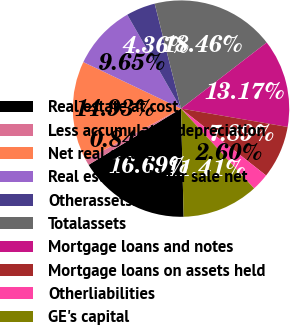Convert chart to OTSL. <chart><loc_0><loc_0><loc_500><loc_500><pie_chart><fcel>Real estate at cost<fcel>Less accumulated depreciation<fcel>Net real estate<fcel>Real estate held for sale net<fcel>Otherassetsnet<fcel>Totalassets<fcel>Mortgage loans and notes<fcel>Mortgage loans on assets held<fcel>Otherliabilities<fcel>GE's capital<nl><fcel>16.69%<fcel>0.84%<fcel>14.93%<fcel>9.65%<fcel>4.36%<fcel>18.46%<fcel>13.17%<fcel>7.89%<fcel>2.6%<fcel>11.41%<nl></chart> 